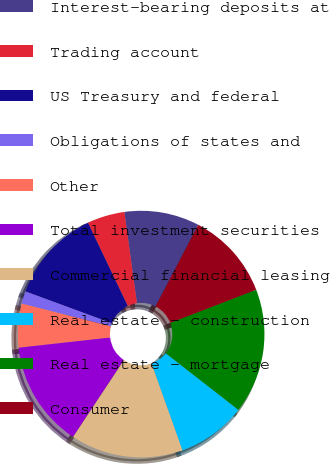<chart> <loc_0><loc_0><loc_500><loc_500><pie_chart><fcel>Interest-bearing deposits at<fcel>Trading account<fcel>US Treasury and federal<fcel>Obligations of states and<fcel>Other<fcel>Total investment securities<fcel>Commercial financial leasing<fcel>Real estate - construction<fcel>Real estate - mortgage<fcel>Consumer<nl><fcel>9.84%<fcel>4.92%<fcel>12.29%<fcel>1.64%<fcel>5.74%<fcel>13.93%<fcel>14.75%<fcel>9.02%<fcel>16.39%<fcel>11.47%<nl></chart> 